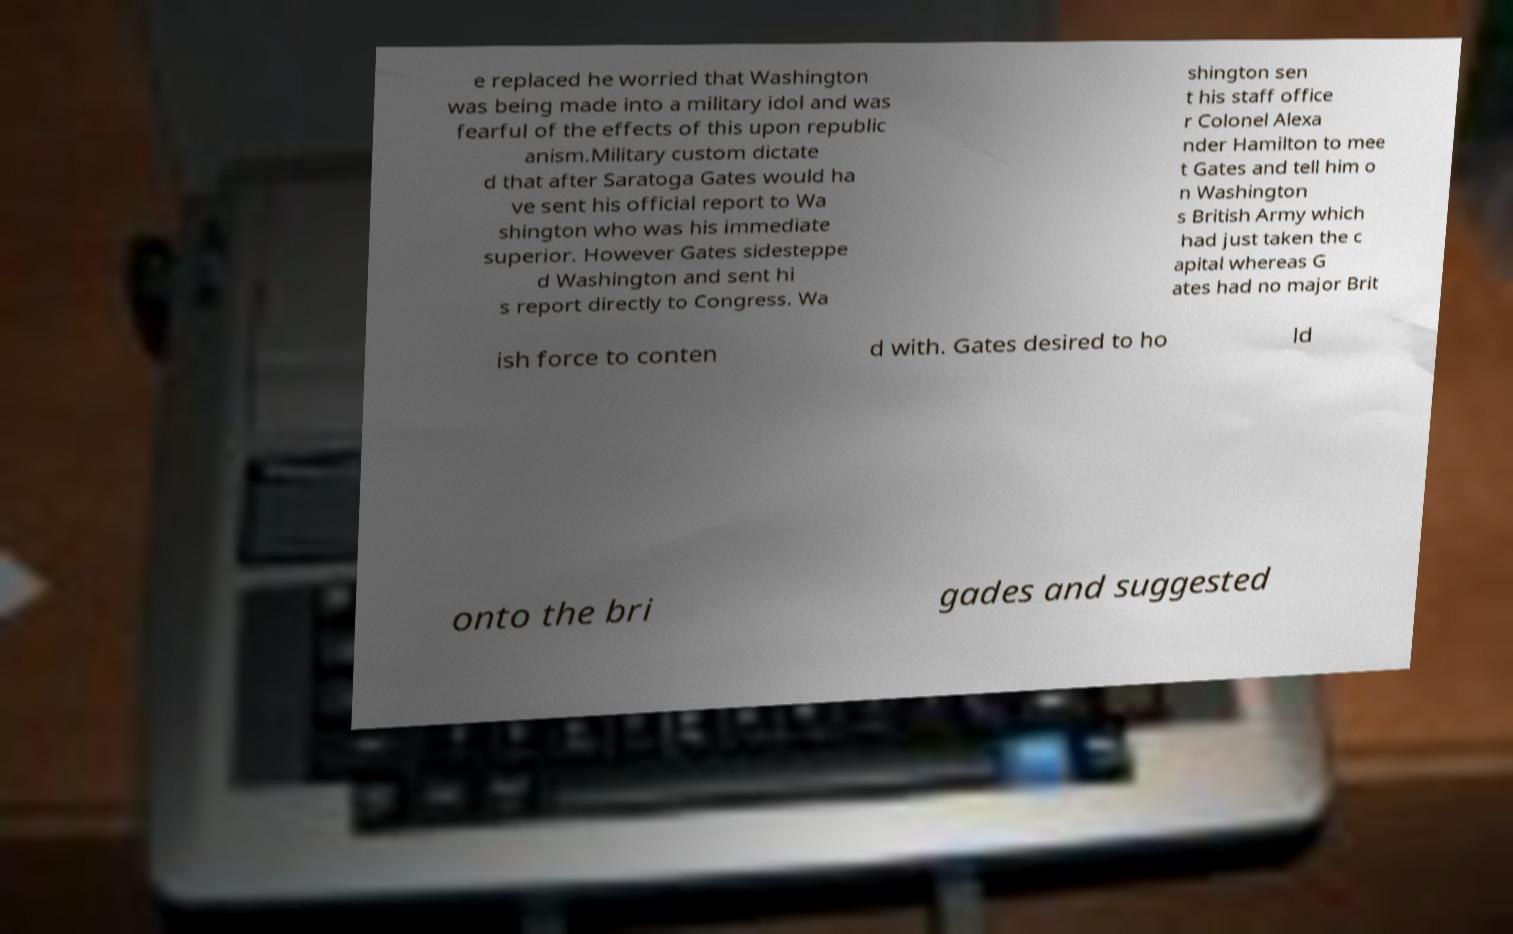Please identify and transcribe the text found in this image. e replaced he worried that Washington was being made into a military idol and was fearful of the effects of this upon republic anism.Military custom dictate d that after Saratoga Gates would ha ve sent his official report to Wa shington who was his immediate superior. However Gates sidesteppe d Washington and sent hi s report directly to Congress. Wa shington sen t his staff office r Colonel Alexa nder Hamilton to mee t Gates and tell him o n Washington s British Army which had just taken the c apital whereas G ates had no major Brit ish force to conten d with. Gates desired to ho ld onto the bri gades and suggested 